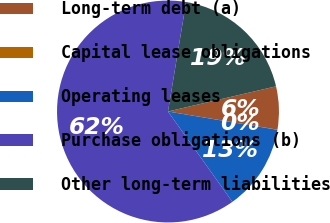<chart> <loc_0><loc_0><loc_500><loc_500><pie_chart><fcel>Long-term debt (a)<fcel>Capital lease obligations<fcel>Operating leases<fcel>Purchase obligations (b)<fcel>Other long-term liabilities<nl><fcel>6.26%<fcel>0.02%<fcel>12.51%<fcel>62.47%<fcel>18.75%<nl></chart> 